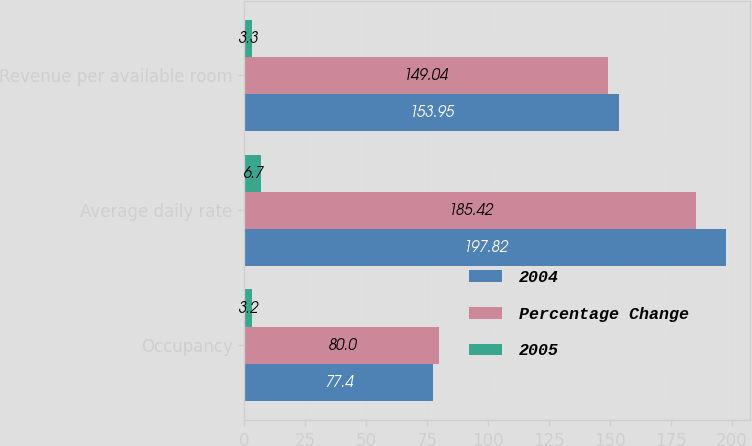Convert chart. <chart><loc_0><loc_0><loc_500><loc_500><stacked_bar_chart><ecel><fcel>Occupancy<fcel>Average daily rate<fcel>Revenue per available room<nl><fcel>2004<fcel>77.4<fcel>197.82<fcel>153.95<nl><fcel>Percentage Change<fcel>80<fcel>185.42<fcel>149.04<nl><fcel>2005<fcel>3.2<fcel>6.7<fcel>3.3<nl></chart> 